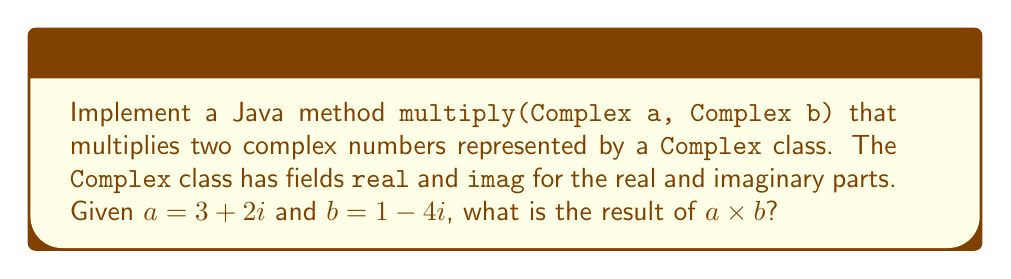Show me your answer to this math problem. To multiply two complex numbers $a = a_1 + a_2i$ and $b = b_1 + b_2i$, we use the formula:

$$(a_1 + a_2i)(b_1 + b_2i) = (a_1b_1 - a_2b_2) + (a_1b_2 + a_2b_1)i$$

Let's implement this in Java:

```java
public class Complex {
    double real;
    double imag;

    public Complex(double real, double imag) {
        this.real = real;
        this.imag = imag;
    }

    public static Complex multiply(Complex a, Complex b) {
        double realPart = a.real * b.real - a.imag * b.imag;
        double imagPart = a.real * b.imag + a.imag * b.real;
        return new Complex(realPart, imagPart);
    }
}
```

Now, let's calculate $a \times b$ where $a = 3 + 2i$ and $b = 1 - 4i$:

1. $a_1 = 3$, $a_2 = 2$, $b_1 = 1$, $b_2 = -4$
2. Real part: $a_1b_1 - a_2b_2 = (3 \times 1) - (2 \times (-4)) = 3 + 8 = 11$
3. Imaginary part: $a_1b_2 + a_2b_1 = (3 \times (-4)) + (2 \times 1) = -12 + 2 = -10$

Therefore, $a \times b = 11 - 10i$
Answer: $11 - 10i$ 